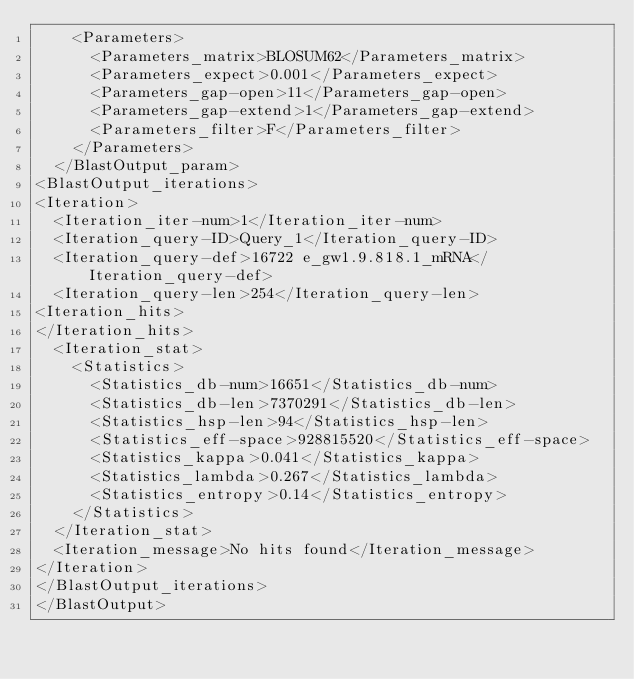Convert code to text. <code><loc_0><loc_0><loc_500><loc_500><_XML_>    <Parameters>
      <Parameters_matrix>BLOSUM62</Parameters_matrix>
      <Parameters_expect>0.001</Parameters_expect>
      <Parameters_gap-open>11</Parameters_gap-open>
      <Parameters_gap-extend>1</Parameters_gap-extend>
      <Parameters_filter>F</Parameters_filter>
    </Parameters>
  </BlastOutput_param>
<BlastOutput_iterations>
<Iteration>
  <Iteration_iter-num>1</Iteration_iter-num>
  <Iteration_query-ID>Query_1</Iteration_query-ID>
  <Iteration_query-def>16722 e_gw1.9.818.1_mRNA</Iteration_query-def>
  <Iteration_query-len>254</Iteration_query-len>
<Iteration_hits>
</Iteration_hits>
  <Iteration_stat>
    <Statistics>
      <Statistics_db-num>16651</Statistics_db-num>
      <Statistics_db-len>7370291</Statistics_db-len>
      <Statistics_hsp-len>94</Statistics_hsp-len>
      <Statistics_eff-space>928815520</Statistics_eff-space>
      <Statistics_kappa>0.041</Statistics_kappa>
      <Statistics_lambda>0.267</Statistics_lambda>
      <Statistics_entropy>0.14</Statistics_entropy>
    </Statistics>
  </Iteration_stat>
  <Iteration_message>No hits found</Iteration_message>
</Iteration>
</BlastOutput_iterations>
</BlastOutput>

</code> 